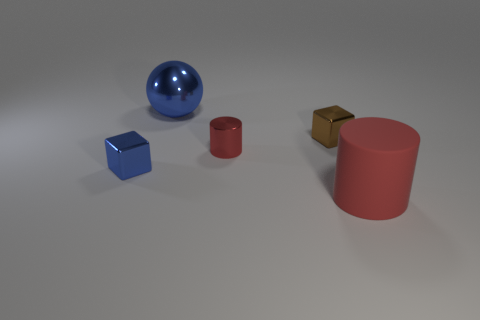If this were a part of a larger scene, what kind of environment could these objects belong to? These objects, with their simple geometric shapes and bold colors, could belong to a variety of environments. They might be found in an educational setting, like a classroom, where they are used as teaching aids for lessons in geometry or color theory. Alternatively, they could be components of a modern art installation, designed to engage viewers with their forms and the interplay of light on their surfaces. 